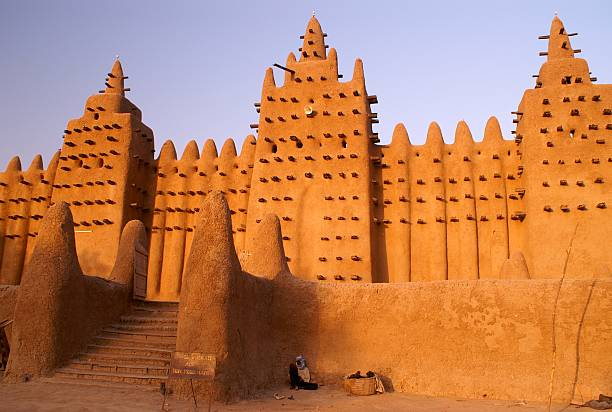What are the main architectural features of the mosque, and how do they contribute to its overall design? The main architectural features of the Great Mosque of Djenné include its massive adobe walls, protruding wooden beams, conical towers, and intricate minarets. The thick, mud-brick walls, capable of withstanding the harsh climatic conditions, provide natural insulation. Rows of toron beams stick out from the walls, not only serving a structural purpose during construction and repairs but also creating interesting play of light and shadow. Three prominent minarets, adorned with stepped designs and crowned with the symbolic ostrich eggs, punctuate the skyline, giving the mosque its iconic look. These minarets stand at varying heights, contributing to the mosque's asymmetrical and organic design. The open courtyard allows for communal gatherings, while intricate detailing on the facade reflects the craftsmanship of the local artisans. Collectively, these features ensure the mosque is both a functional place of worship and a masterclass in Sudano-Sahelian architecture. 